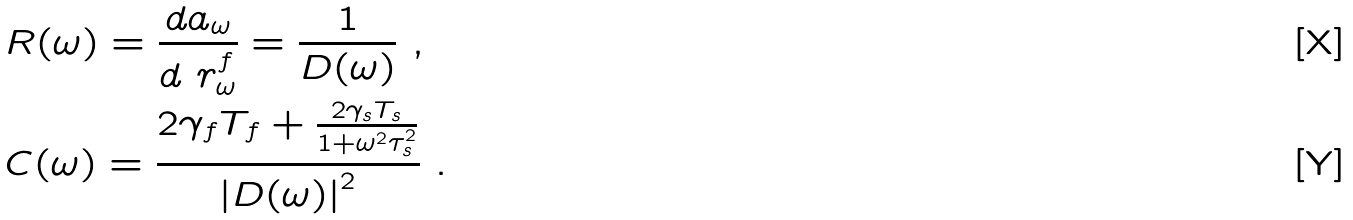<formula> <loc_0><loc_0><loc_500><loc_500>& R ( \omega ) = \frac { d a _ { \omega } } { d \ r ^ { f } _ { \omega } } = \frac { 1 } { D ( \omega ) } \ , \\ & C ( \omega ) = \frac { 2 \gamma _ { f } T _ { f } + \frac { 2 \gamma _ { s } T _ { s } } { 1 + \omega ^ { 2 } \tau _ { s } ^ { 2 } } } { \left | D ( \omega ) \right | ^ { 2 } } \ .</formula> 